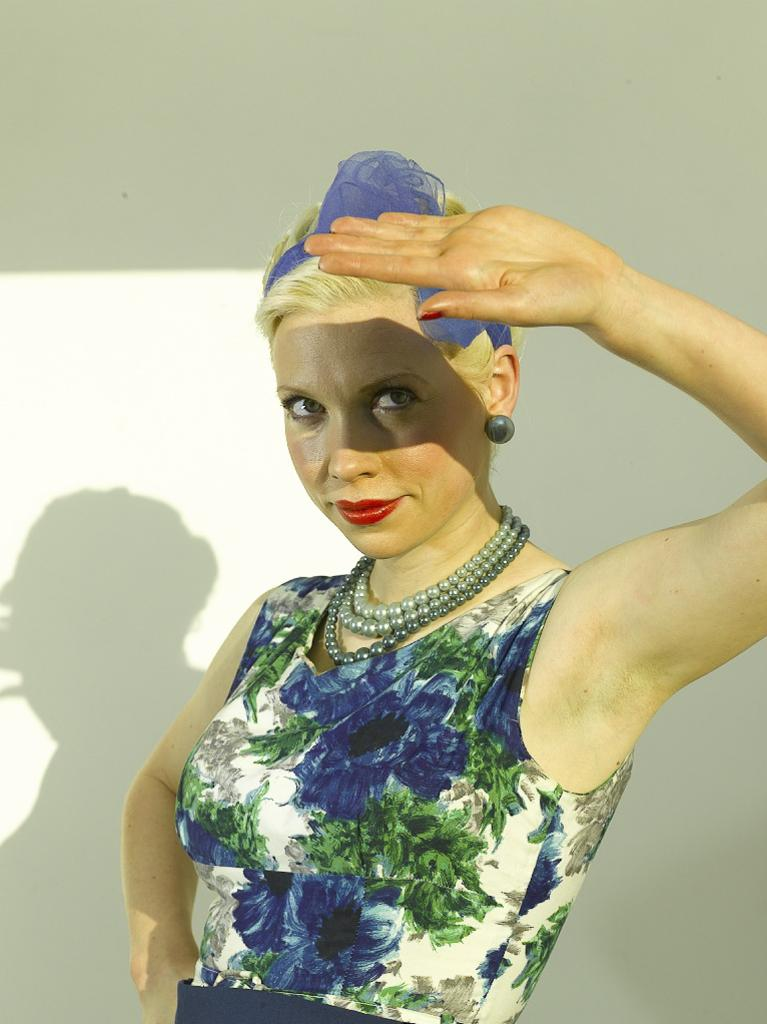Who is present in the image? There is a woman in the image. What can be observed about the woman's shadow in the image? The shadow of the woman is visible on the wall in the background. How many girls are playing with the tub in the image? There is no tub or girls present in the image; it only features a woman and her shadow. 